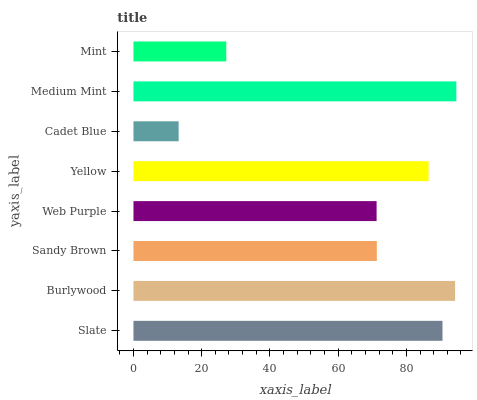Is Cadet Blue the minimum?
Answer yes or no. Yes. Is Medium Mint the maximum?
Answer yes or no. Yes. Is Burlywood the minimum?
Answer yes or no. No. Is Burlywood the maximum?
Answer yes or no. No. Is Burlywood greater than Slate?
Answer yes or no. Yes. Is Slate less than Burlywood?
Answer yes or no. Yes. Is Slate greater than Burlywood?
Answer yes or no. No. Is Burlywood less than Slate?
Answer yes or no. No. Is Yellow the high median?
Answer yes or no. Yes. Is Sandy Brown the low median?
Answer yes or no. Yes. Is Medium Mint the high median?
Answer yes or no. No. Is Burlywood the low median?
Answer yes or no. No. 